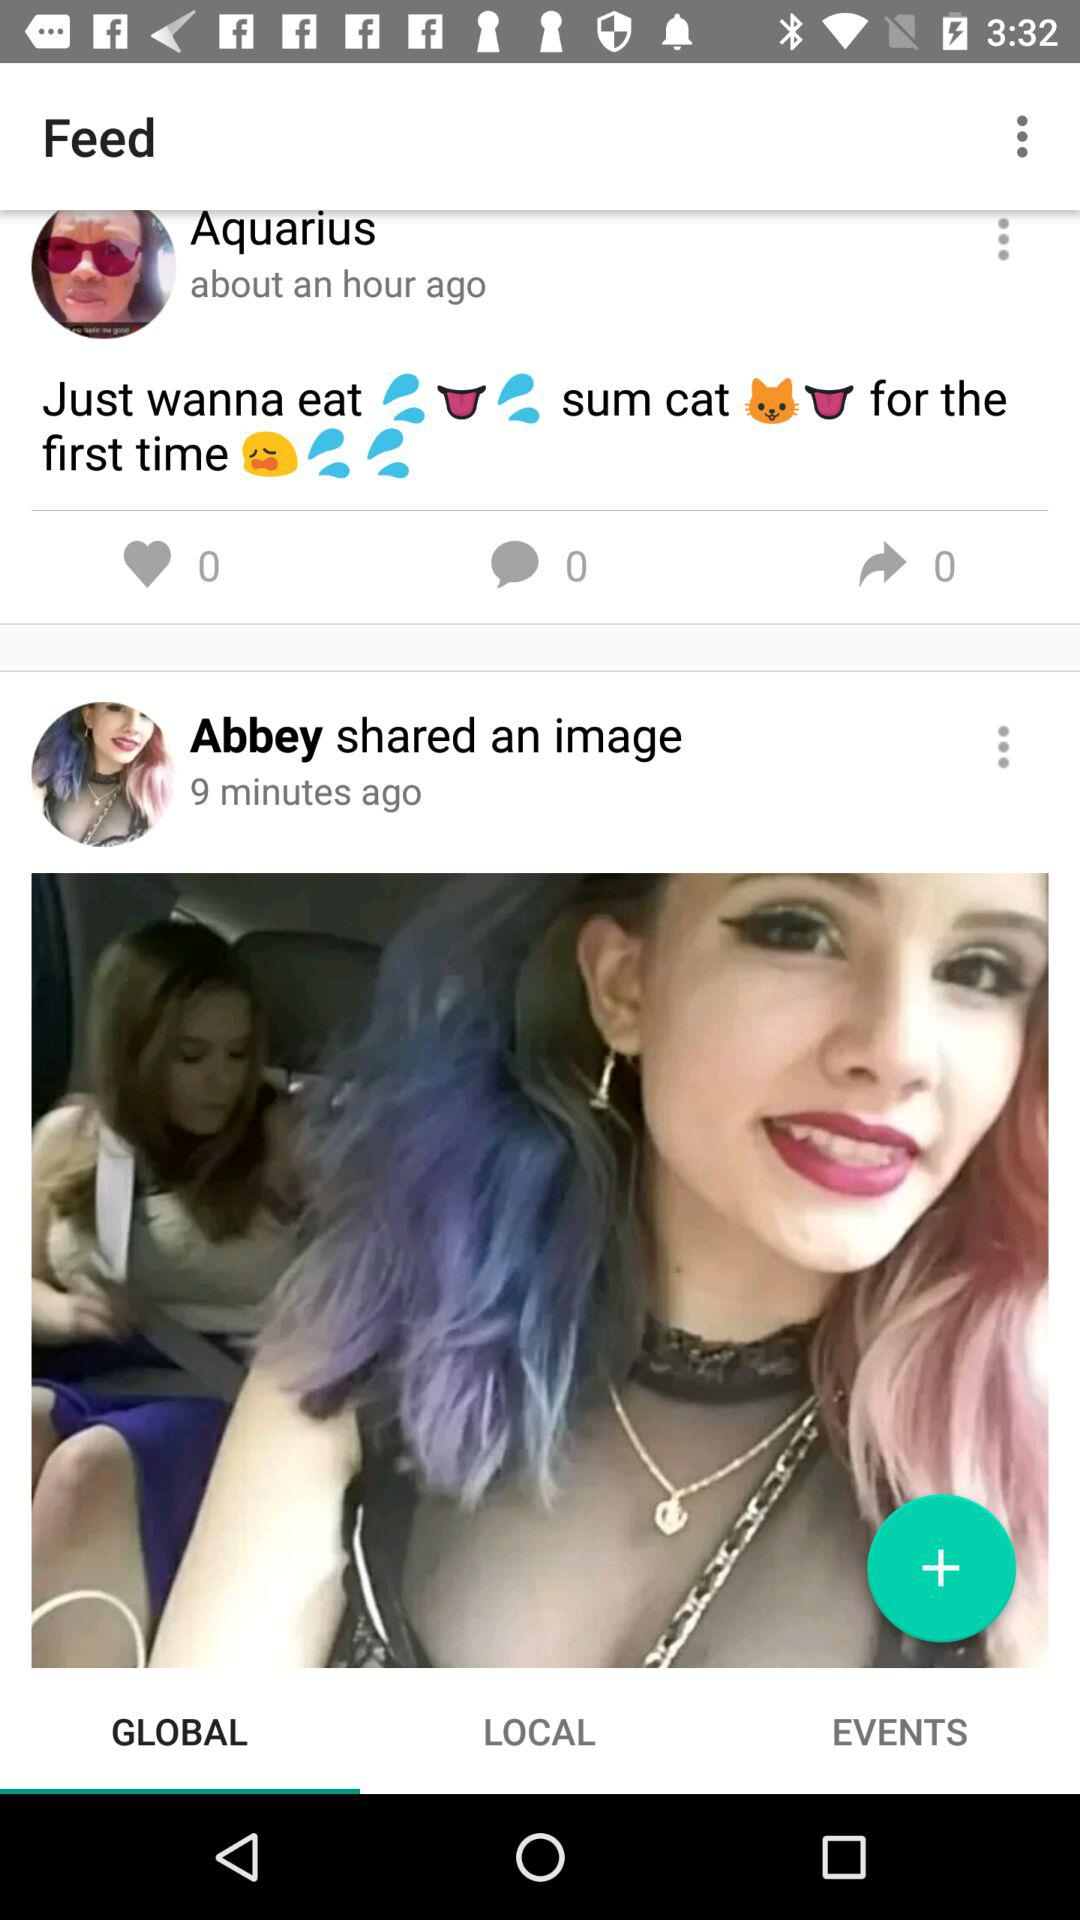How many minutes ago did Abbey share the image? The image was shared 9 minutes ago. 